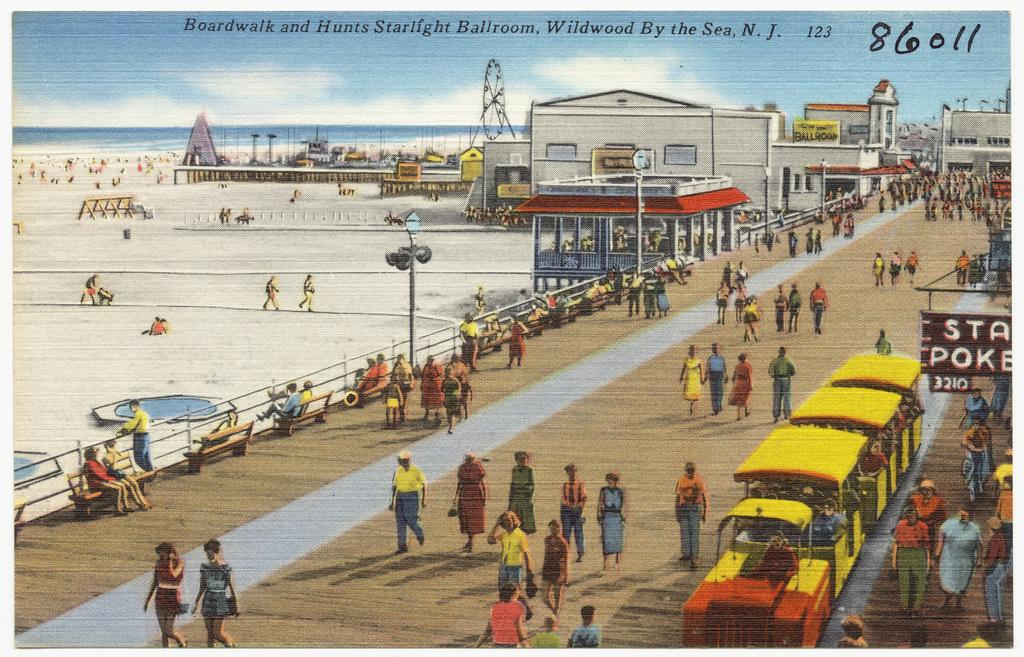Provide a one-sentence caption for the provided image. Boardwalk and Hunts starlight Ballroom by the sea N.J. 